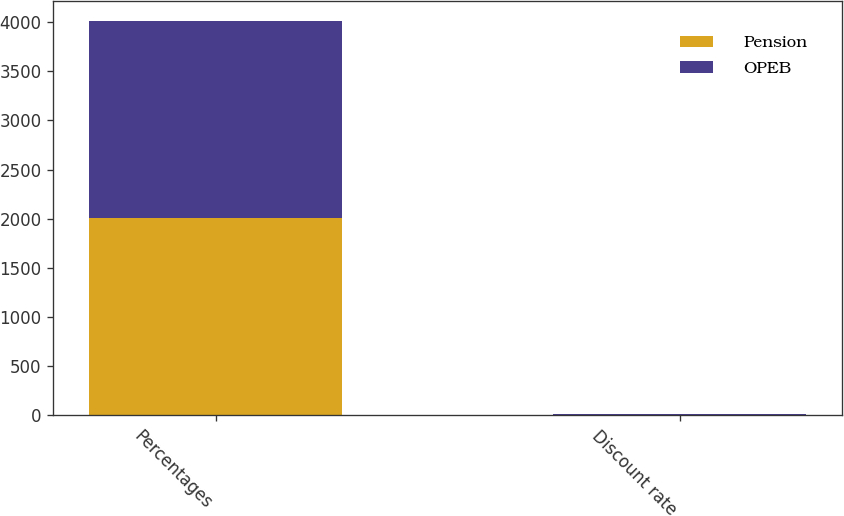<chart> <loc_0><loc_0><loc_500><loc_500><stacked_bar_chart><ecel><fcel>Percentages<fcel>Discount rate<nl><fcel>Pension<fcel>2009<fcel>6.25<nl><fcel>OPEB<fcel>2009<fcel>6.25<nl></chart> 